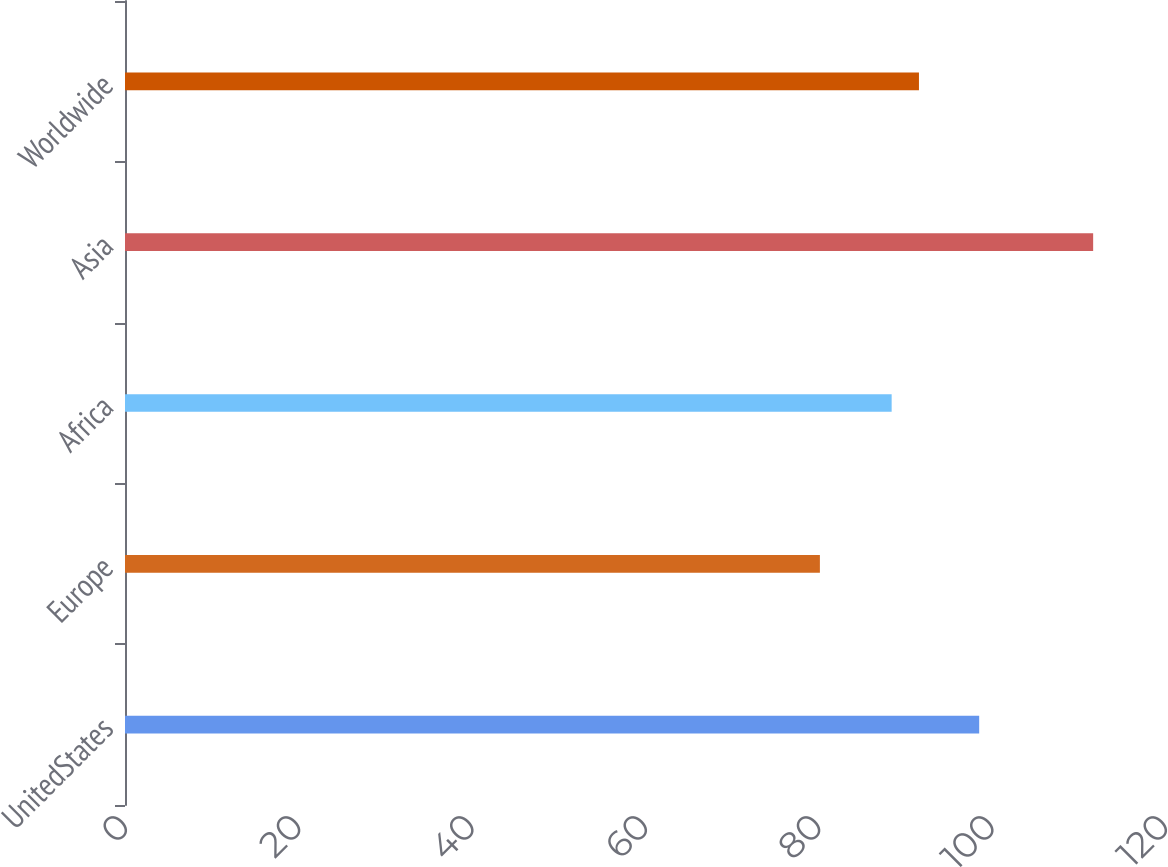<chart> <loc_0><loc_0><loc_500><loc_500><bar_chart><fcel>UnitedStates<fcel>Europe<fcel>Africa<fcel>Asia<fcel>Worldwide<nl><fcel>98.56<fcel>80.18<fcel>88.46<fcel>111.71<fcel>91.61<nl></chart> 